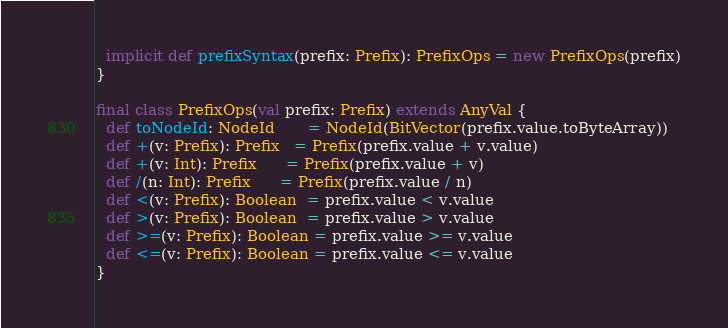Convert code to text. <code><loc_0><loc_0><loc_500><loc_500><_Scala_>  implicit def prefixSyntax(prefix: Prefix): PrefixOps = new PrefixOps(prefix)
}

final class PrefixOps(val prefix: Prefix) extends AnyVal {
  def toNodeId: NodeId       = NodeId(BitVector(prefix.value.toByteArray))
  def +(v: Prefix): Prefix   = Prefix(prefix.value + v.value)
  def +(v: Int): Prefix      = Prefix(prefix.value + v)
  def /(n: Int): Prefix      = Prefix(prefix.value / n)
  def <(v: Prefix): Boolean  = prefix.value < v.value
  def >(v: Prefix): Boolean  = prefix.value > v.value
  def >=(v: Prefix): Boolean = prefix.value >= v.value
  def <=(v: Prefix): Boolean = prefix.value <= v.value
}
</code> 